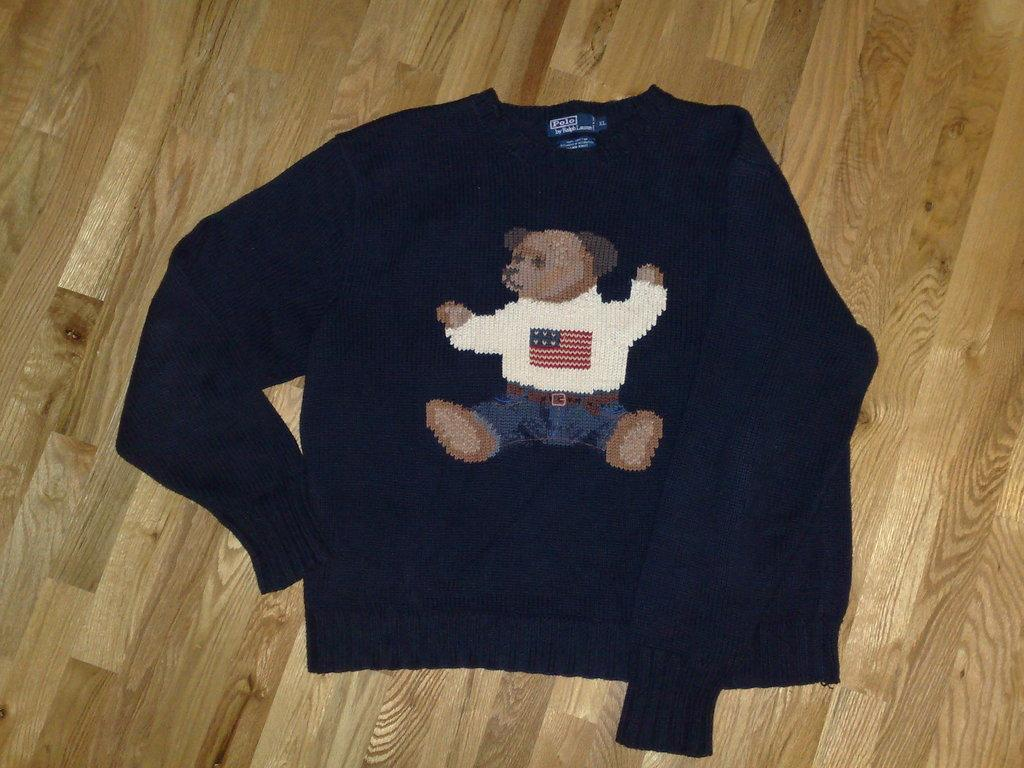What color is the T-shirt in the image? The T-shirt in the image is blue. Where is the T-shirt located in the image? The T-shirt is on the floor in the image. What design is on the T-shirt? There is a teddy art on the T-shirt. What type of pan is being used to cook the T-shirt in the image? There is no pan or cooking involved in the image; it simply shows a blue T-shirt with a teddy art design on the floor. 